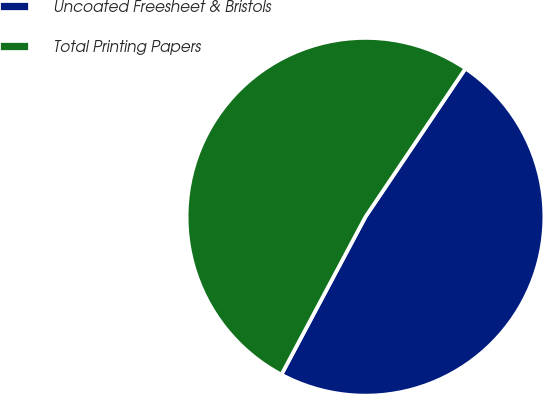Convert chart to OTSL. <chart><loc_0><loc_0><loc_500><loc_500><pie_chart><fcel>Uncoated Freesheet & Bristols<fcel>Total Printing Papers<nl><fcel>48.35%<fcel>51.65%<nl></chart> 